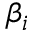<formula> <loc_0><loc_0><loc_500><loc_500>\beta _ { i }</formula> 